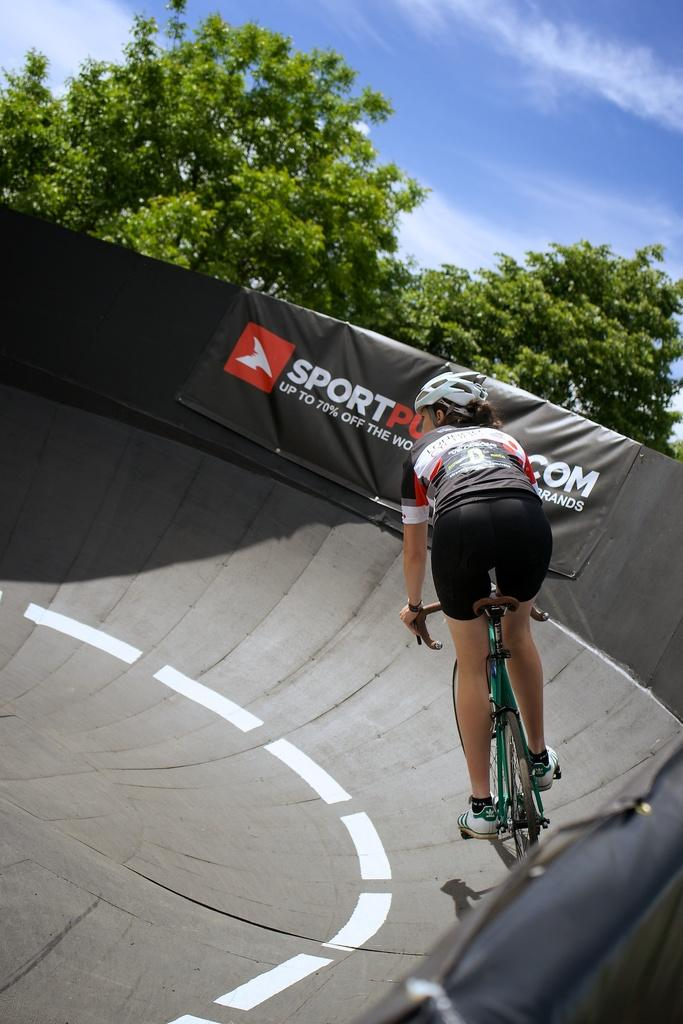Who is the main subject in the image? There is a lady in the image. What is the lady wearing on her head? The lady is wearing a helmet. What accessory can be seen on the lady's wrist? The lady is wearing a watch. What is the lady doing in the image? The lady is riding a cycle. What is the cycle resting on? The cycle is on a surface. What is present on the side of the image? There is a banner on the side of the image. What can be seen in the background of the image? There are trees and the sky visible in the background of the image. How many brothers does the lady have, and where are they in the image? There is no information about the lady's brothers in the image, so we cannot determine their number or location. 